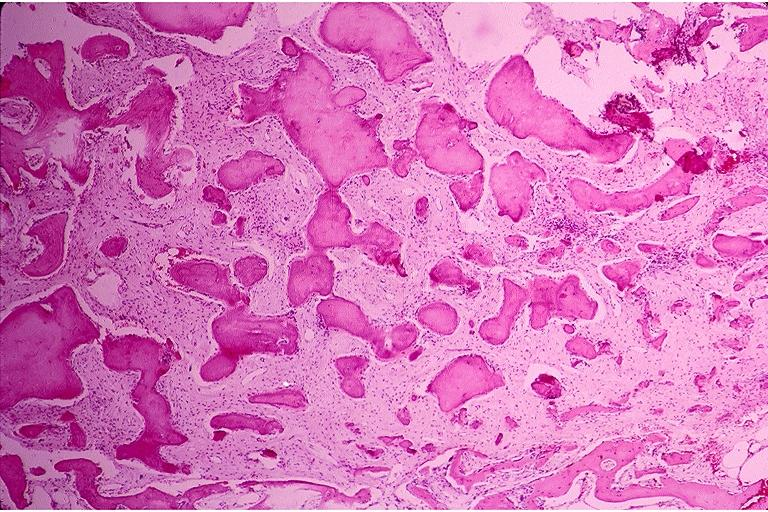does this image show benign fibro-osseous lesion?
Answer the question using a single word or phrase. Yes 